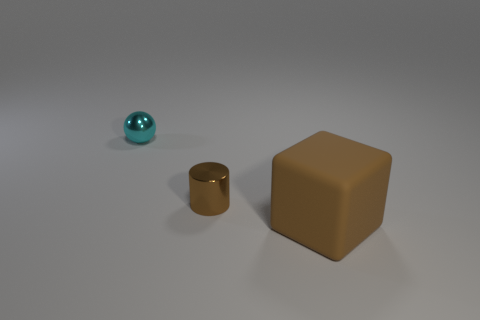There is a small cylinder that is made of the same material as the small cyan ball; what is its color?
Provide a succinct answer. Brown. Are there more tiny red matte cylinders than big cubes?
Give a very brief answer. No. Is the cylinder made of the same material as the small cyan sphere?
Offer a very short reply. Yes. There is a small thing that is the same material as the cyan sphere; what shape is it?
Offer a very short reply. Cylinder. Are there fewer large green matte cubes than large brown matte blocks?
Your response must be concise. Yes. There is a thing that is in front of the cyan metal sphere and behind the big brown thing; what is its material?
Make the answer very short. Metal. There is a metal object that is behind the tiny thing in front of the small shiny object that is on the left side of the small brown cylinder; how big is it?
Provide a succinct answer. Small. There is a small brown metal thing; is it the same shape as the brown object that is in front of the cylinder?
Provide a succinct answer. No. How many objects are both in front of the cyan thing and behind the large cube?
Provide a succinct answer. 1. What number of cyan objects are either metallic things or metallic cylinders?
Provide a short and direct response. 1. 